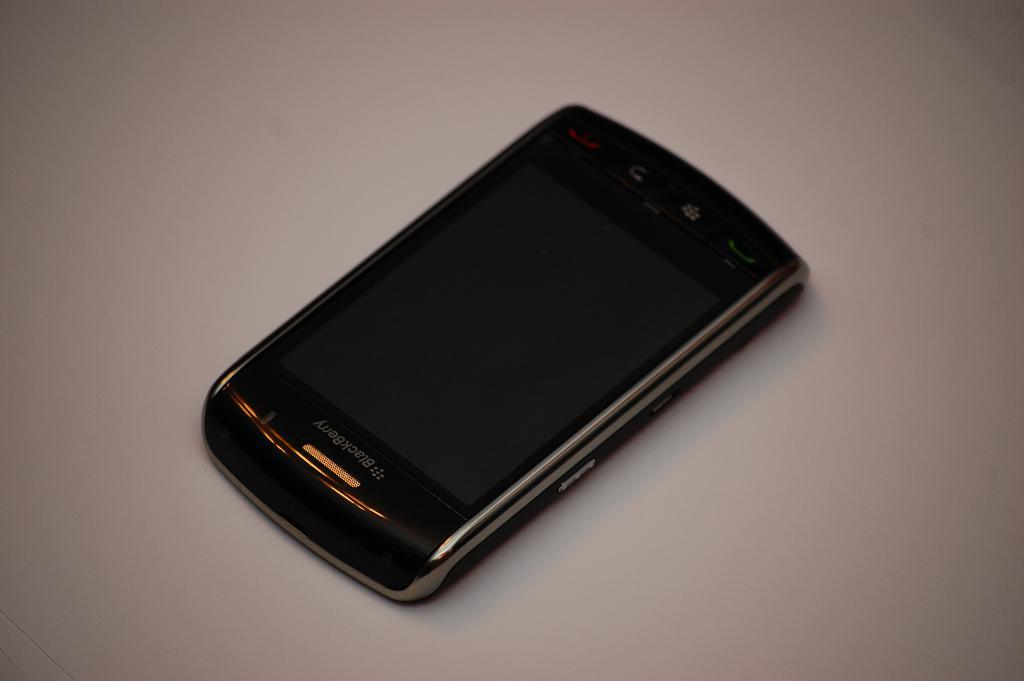<image>
Share a concise interpretation of the image provided. A blackberry with its screen off is on a light tan counter. 